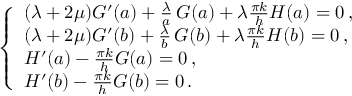<formula> <loc_0><loc_0><loc_500><loc_500>\left \{ \begin{array} { l l } { ( \lambda + 2 \mu ) G ^ { \prime } ( a ) + \frac { \lambda } { a } \, G ( a ) + \lambda \frac { \pi k } { h } H ( a ) = 0 \, , } \\ { ( \lambda + 2 \mu ) G ^ { \prime } ( b ) + \frac { \lambda } { b } \, G ( b ) + \lambda \frac { \pi k } { h } H ( b ) = 0 \, , } \\ { H ^ { \prime } ( a ) - \frac { \pi k } { h } G ( a ) = 0 \, , } \\ { H ^ { \prime } ( b ) - \frac { \pi k } { h } G ( b ) = 0 \, . } \end{array}</formula> 